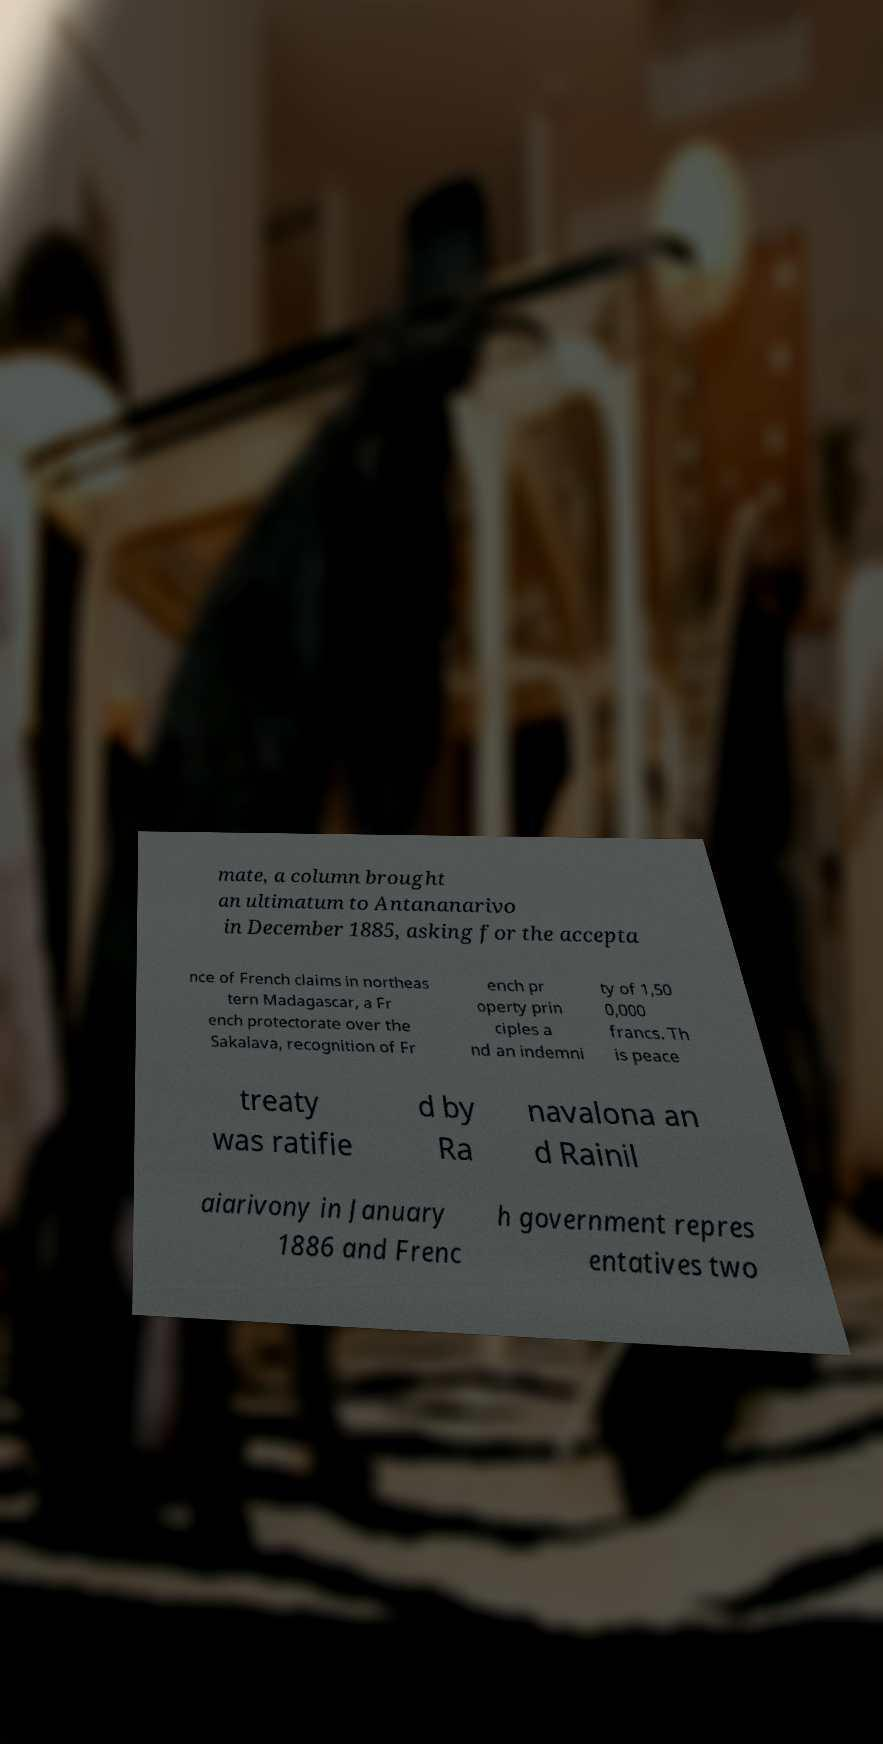For documentation purposes, I need the text within this image transcribed. Could you provide that? mate, a column brought an ultimatum to Antananarivo in December 1885, asking for the accepta nce of French claims in northeas tern Madagascar, a Fr ench protectorate over the Sakalava, recognition of Fr ench pr operty prin ciples a nd an indemni ty of 1,50 0,000 francs. Th is peace treaty was ratifie d by Ra navalona an d Rainil aiarivony in January 1886 and Frenc h government repres entatives two 